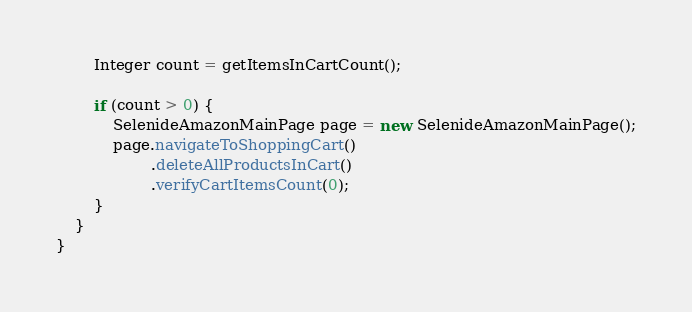Convert code to text. <code><loc_0><loc_0><loc_500><loc_500><_Java_>
        Integer count = getItemsInCartCount();

        if (count > 0) {
            SelenideAmazonMainPage page = new SelenideAmazonMainPage();
            page.navigateToShoppingCart()
                    .deleteAllProductsInCart()
                    .verifyCartItemsCount(0);
        }
    }
}
</code> 